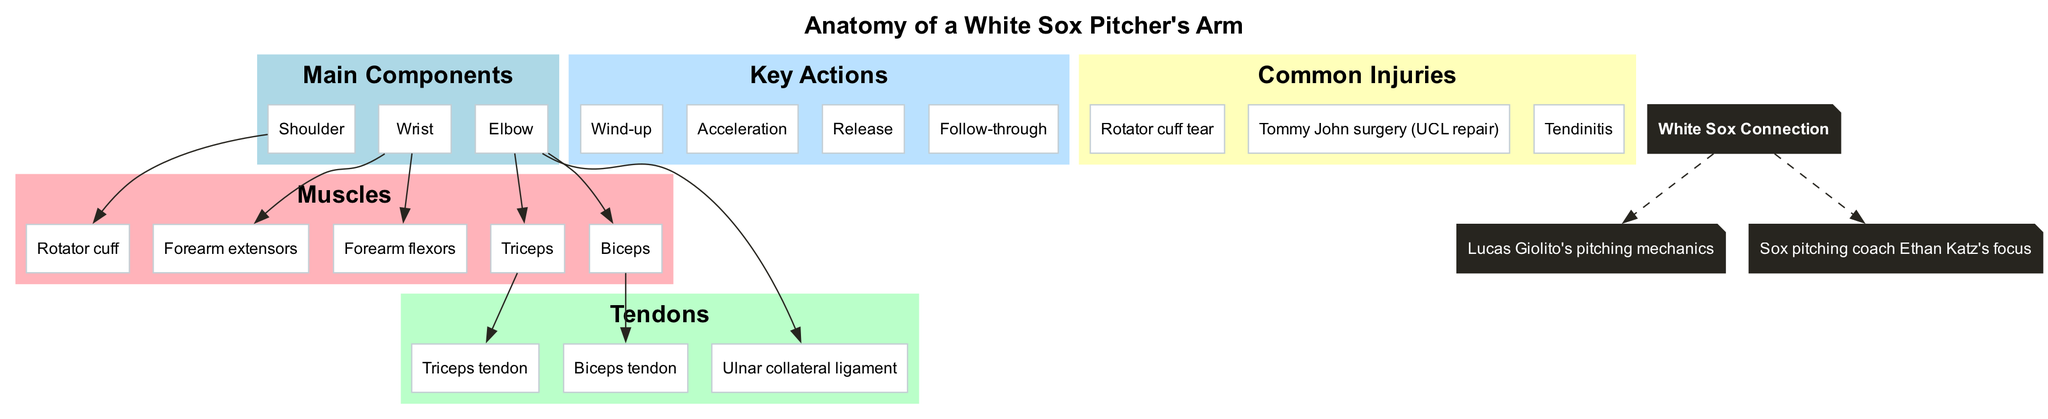What are the main components of the pitcher's arm? The diagram lists the main components as "Shoulder," "Elbow," and "Wrist." These components serve as the primary sections of the arm related to pitching.
Answer: Shoulder, Elbow, Wrist How many muscles are involved in throwing? The diagram indicates that there are five muscles involved in throwing, as outlined in the muscles section. This includes the rotator cuff, biceps, triceps, forearm flexors, and forearm extensors.
Answer: 5 Which muscle is connected to the elbow? According to the diagram, both the biceps and the triceps are muscles that are located at the elbow. The elbow connects these two muscles, making them significant in the mechanics of throwing.
Answer: Biceps, Triceps What common injury is associated with the ulnar collateral ligament? Based on the diagram, "Tommy John surgery (UCL repair)" is directly associated with the ulnar collateral ligament, indicating that this injury often necessitates such a surgical procedure.
Answer: Tommy John surgery (UCL repair) What key action happens after the release? The diagram includes “Follow-through” as a key action that occurs after the release when pitching, indicating the final part of the throwing motion.
Answer: Follow-through Which tendon is linked to the biceps? The diagram shows that the "Biceps tendon" is the specific tendon connected to the biceps, highlighting its role in the pitching anatomy.
Answer: Biceps tendon What color represents the tendons in the diagram? The tendons section is represented in "light green" as indicated by the color coding of the subgraph, distinguishing it from other components of the diagram.
Answer: Light green Which player is associated with the White Sox connection? The connection mentions "Lucas Giolito's pitching mechanics," associating him with the focus on pitching techniques relevant to the White Sox team.
Answer: Lucas Giolito's pitching mechanics What is the total number of common injuries listed? The diagram outlines three common injuries related to pitching, showing a clear focus on potential issues that pitchers may face.
Answer: 3 